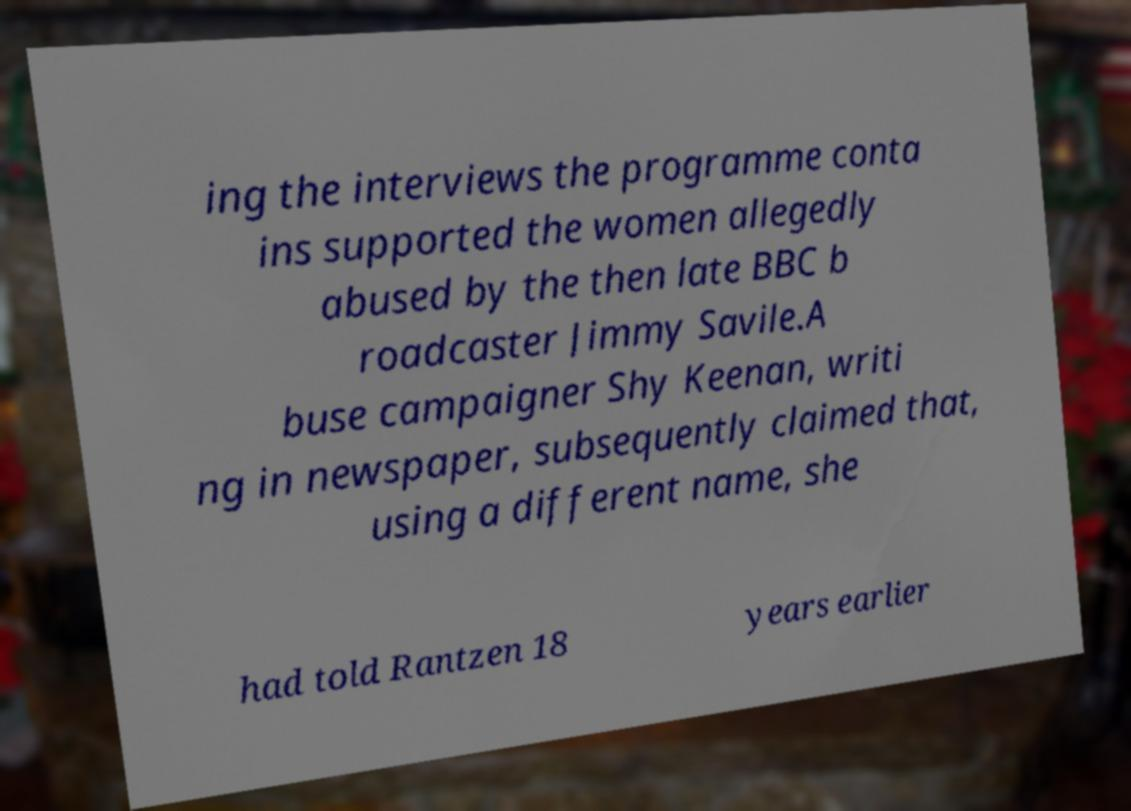Could you assist in decoding the text presented in this image and type it out clearly? ing the interviews the programme conta ins supported the women allegedly abused by the then late BBC b roadcaster Jimmy Savile.A buse campaigner Shy Keenan, writi ng in newspaper, subsequently claimed that, using a different name, she had told Rantzen 18 years earlier 